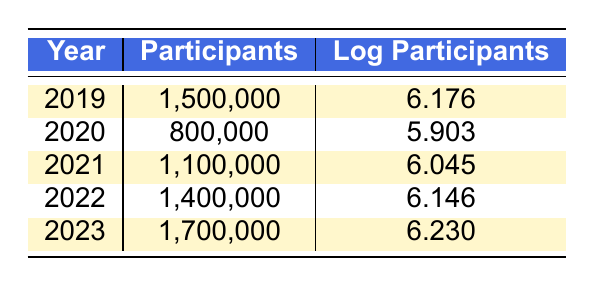What year had the highest number of marathon participants? By inspecting the "Participants" column, the highest value is 1,700,000, which corresponds to the year 2023.
Answer: 2023 What was the number of marathon participants in 2021? The "Participants" column lists 1,100,000 for the year 2021.
Answer: 1,100,000 In which year did marathon participation drop to the lowest number? Observing the "Participants" column, 800,000 is the lowest value, which occurred in the year 2020.
Answer: 2020 What is the total number of participants from 2019 to 2023? The total participants can be calculated as 1,500,000 + 800,000 + 1,100,000 + 1,400,000 + 1,700,000 = 6,500,000.
Answer: 6,500,000 Is it true that marathon participation increased every year from 2019 to 2023? While participation increased from 2019 to 2022 and again in 2023, there was a decrease in participants from 2019 to 2020. Therefore, the statement is false.
Answer: No What was the average number of participants from 2019 to 2023? To find the average, sum the participants (1,500,000 + 800,000 + 1,100,000 + 1,400,000 + 1,700,000 = 6,500,000) and divide by 5, yielding an average of 1,300,000.
Answer: 1,300,000 What is the difference in the number of participants between 2022 and 2020? By subtracting the participants in 2020 (800,000) from those in 2022 (1,400,000), we find the difference is 1,400,000 - 800,000 = 600,000.
Answer: 600,000 Did the logarithmic value of participants increase every year from 2019 to 2023? Evaluating the "Log Participants" column shows the values as follows: 6.176 (2019), 5.903 (2020), 6.045 (2021), 6.146 (2022), and 6.230 (2023). Since 2020 decreased, the statement is false.
Answer: No What was the highest logarithmic value recorded, and in which year did it occur? The highest logarithmic value is 6.230, found in the year 2023.
Answer: 6.230 in 2023 